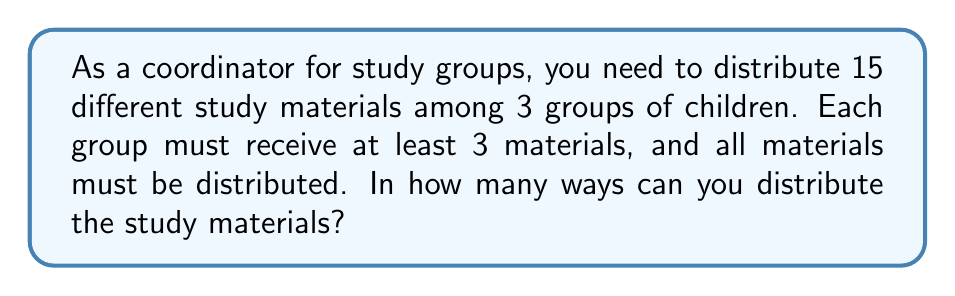What is the answer to this math problem? Let's approach this step-by-step:

1) This is a problem of distributing distinct objects (15 study materials) into distinct groups (3 groups of children), with restrictions on the minimum number of objects per group.

2) We can use the concept of Stirling numbers of the second kind, denoted as $\stirling{n}{k}$, which represents the number of ways to partition n distinct objects into k non-empty subsets.

3) However, we need to account for the restriction that each group must receive at least 3 materials. We can do this by first distributing 3 materials to each group, and then distributing the remaining 6 materials.

4) After giving 3 materials to each group, we have:
   $15 - (3 \times 3) = 6$ materials left to distribute

5) Now, we need to find the number of ways to distribute these 6 materials into 3 groups (which may include empty groups now). This is exactly $\stirling{6}{3}$.

6) The value of $\stirling{6}{3}$ can be calculated as follows:
   $$\stirling{6}{3} = \frac{1}{6}(3^6 - 3 \cdot 2^6 + 3 \cdot 1^6) = 90$$

7) However, this only accounts for one way of distributing the initial 9 materials. We need to multiply this by the number of ways to choose those initial 9 materials, which is $\binom{15}{9}$.

8) $\binom{15}{9} = \frac{15!}{9!(15-9)!} = \frac{15!}{9!6!} = 5005$

9) Therefore, the total number of ways to distribute the materials is:
   $5005 \times 90 = 450,450$
Answer: 450,450 